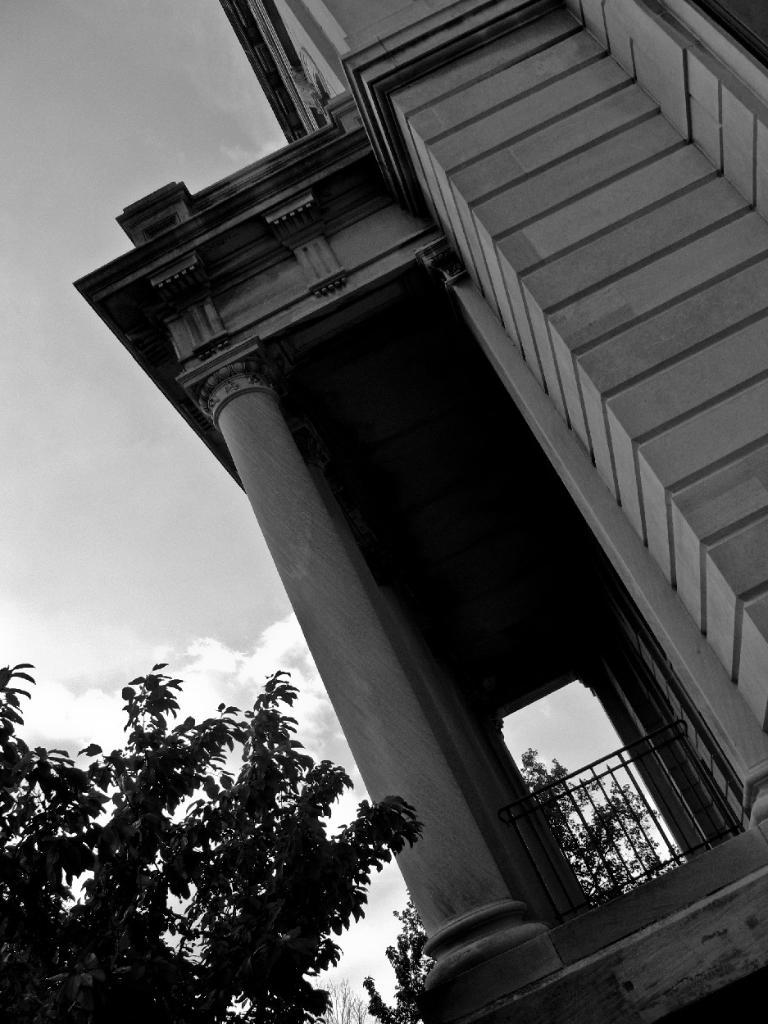What is the color scheme of the image? The image is black and white. What structure can be seen in the image? There is a building in the image. Where are the trees located in relation to the building? The trees are on the left side of the building. What is visible behind the building? The sky is visible behind the building. What type of dog is sitting on the crib in the image? There is no dog or crib present in the image; it features a black and white building with trees on the left side and the sky visible behind it. 